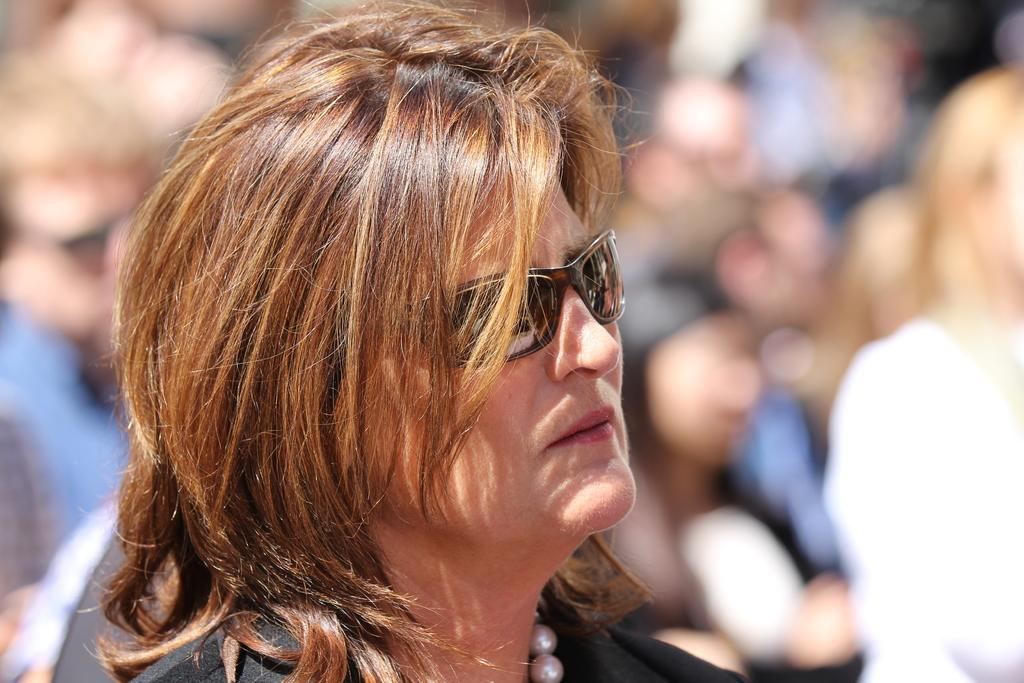Who or what is the main subject of the image? There is a person in the image. Can you describe the background of the image? The background of the image is blurry. What type of robin can be seen perched on the person's shoulder in the image? There is no robin present in the image; it only features a person with a blurry background. What kind of pin is attached to the person's clothing in the image? There is no pin visible on the person's clothing in the image. 